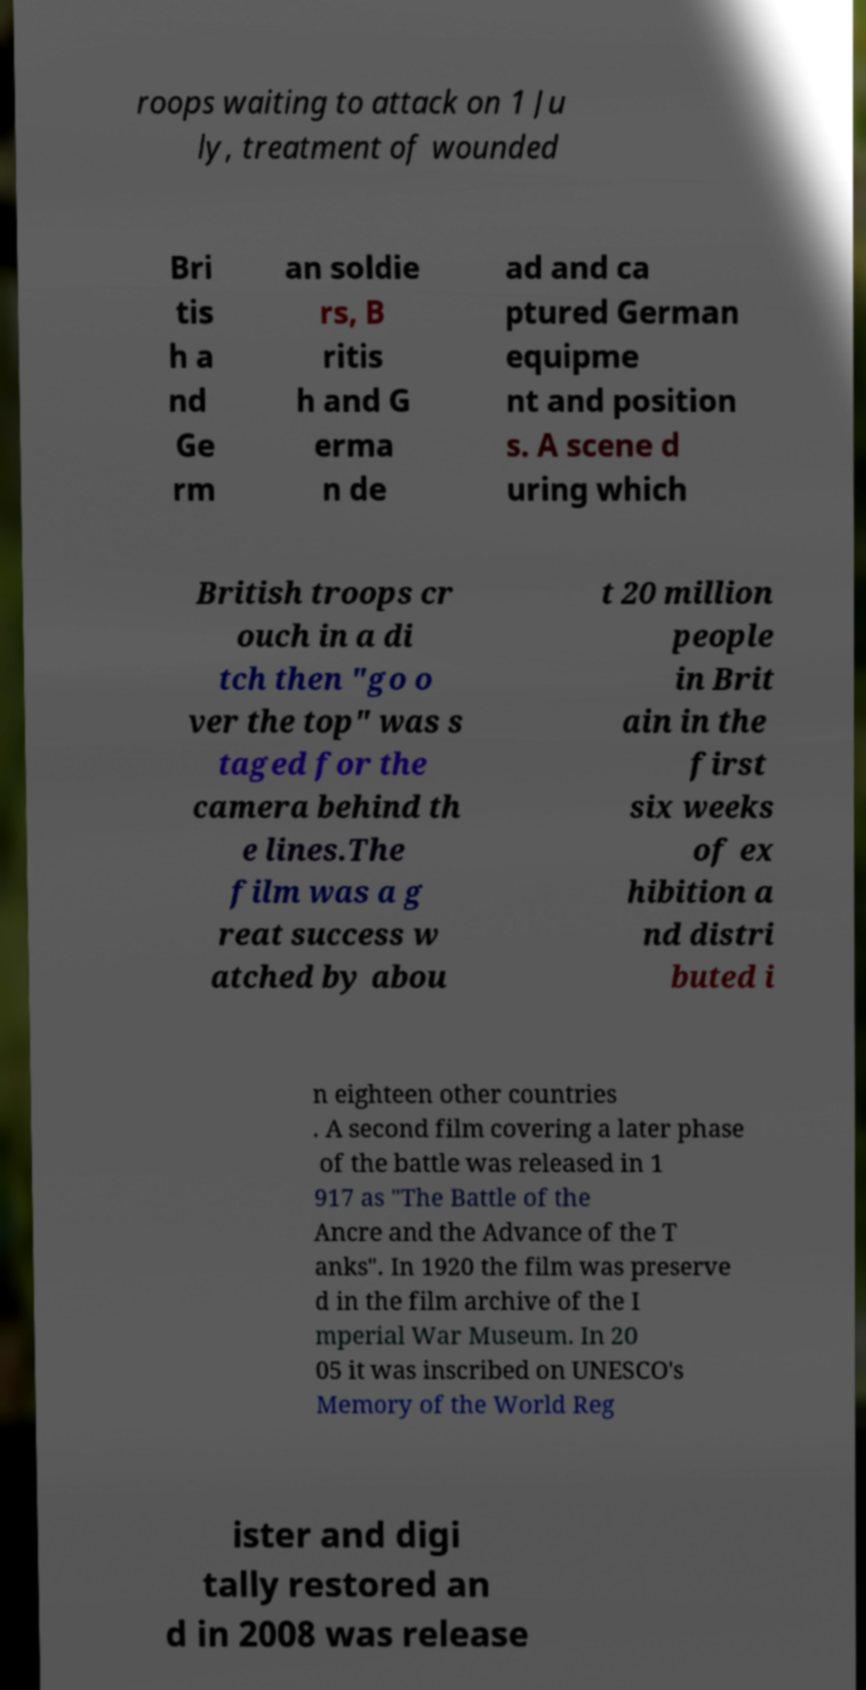Please identify and transcribe the text found in this image. roops waiting to attack on 1 Ju ly, treatment of wounded Bri tis h a nd Ge rm an soldie rs, B ritis h and G erma n de ad and ca ptured German equipme nt and position s. A scene d uring which British troops cr ouch in a di tch then "go o ver the top" was s taged for the camera behind th e lines.The film was a g reat success w atched by abou t 20 million people in Brit ain in the first six weeks of ex hibition a nd distri buted i n eighteen other countries . A second film covering a later phase of the battle was released in 1 917 as "The Battle of the Ancre and the Advance of the T anks". In 1920 the film was preserve d in the film archive of the I mperial War Museum. In 20 05 it was inscribed on UNESCO's Memory of the World Reg ister and digi tally restored an d in 2008 was release 